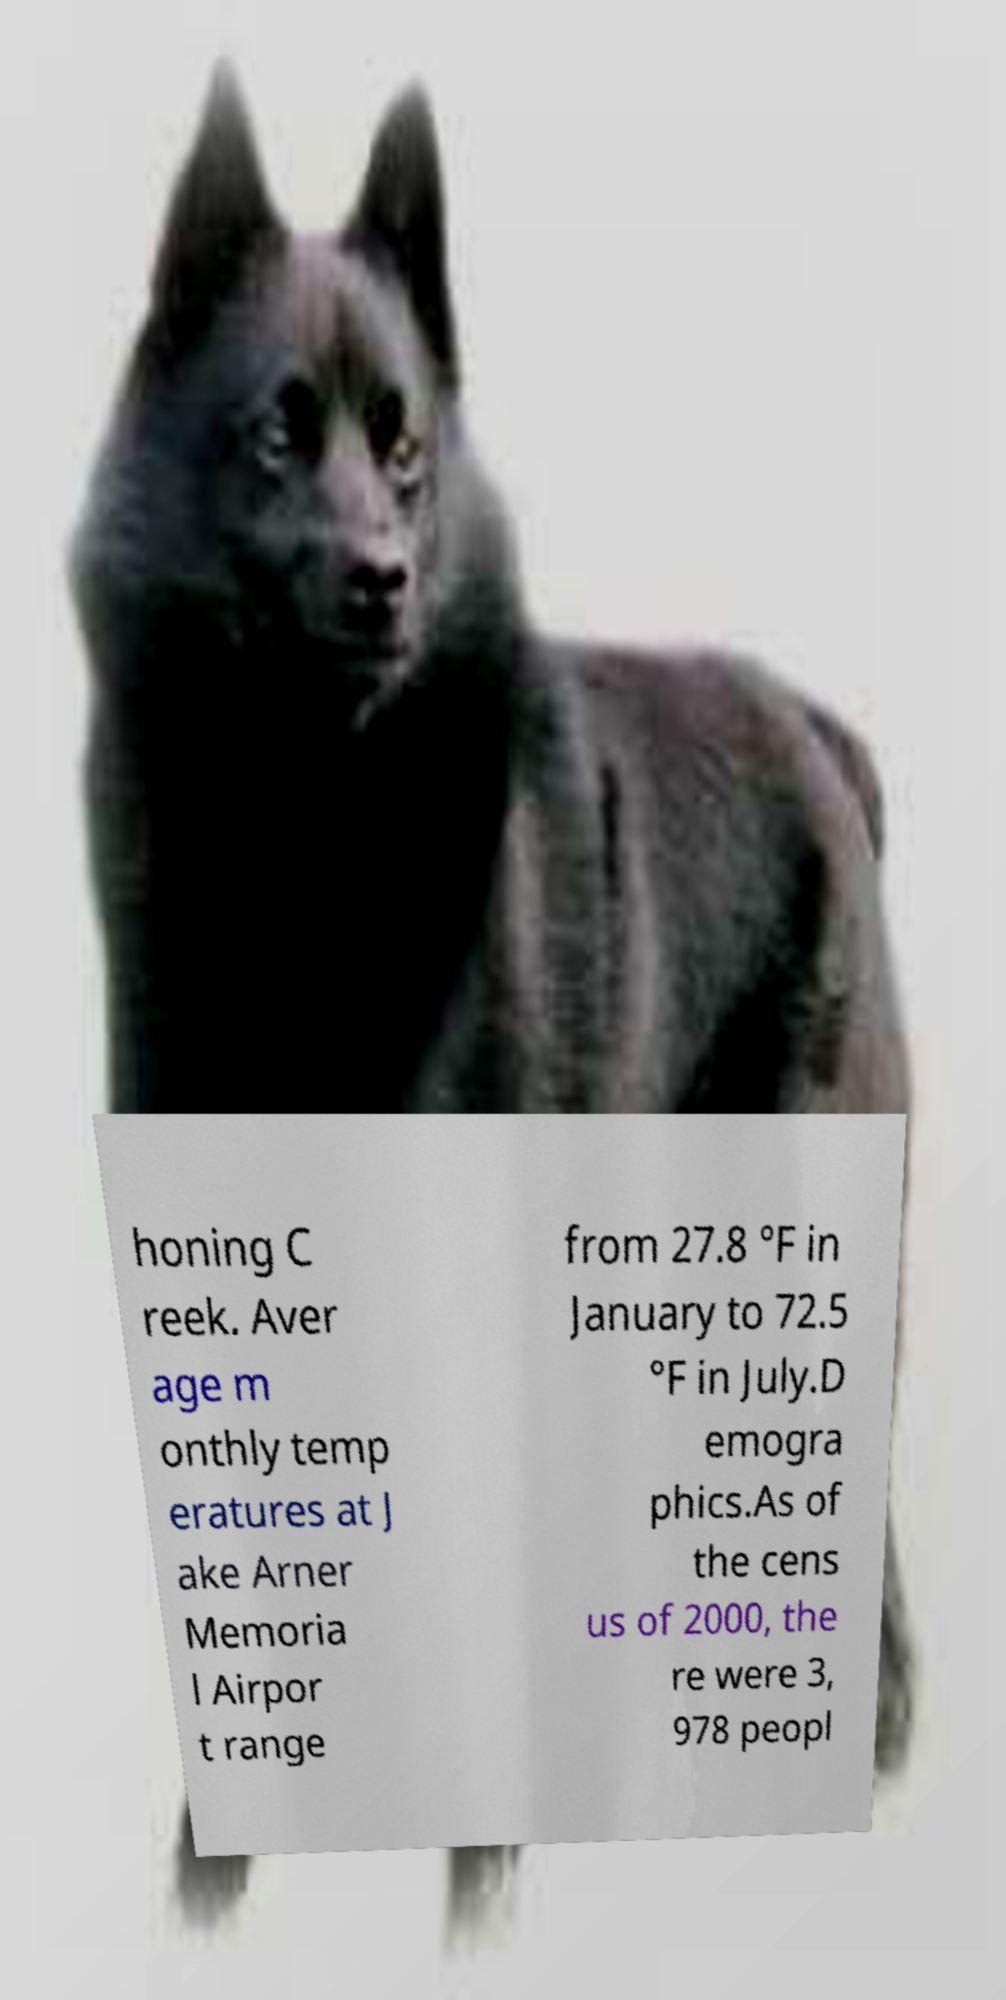Can you accurately transcribe the text from the provided image for me? honing C reek. Aver age m onthly temp eratures at J ake Arner Memoria l Airpor t range from 27.8 °F in January to 72.5 °F in July.D emogra phics.As of the cens us of 2000, the re were 3, 978 peopl 